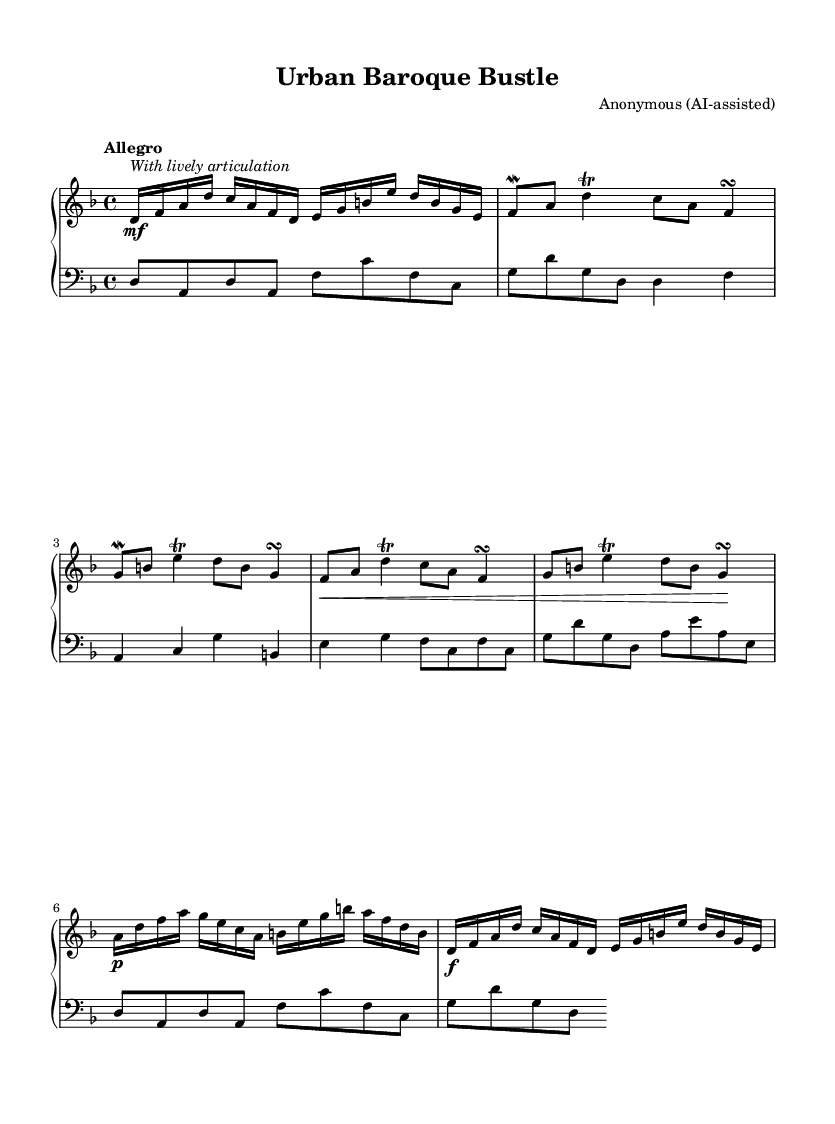What is the key signature of this music? The key signature is D minor, which has one flat (B-flat). This can be confirmed by looking at the key signature indicated at the beginning of the piece.
Answer: D minor What is the time signature of this composition? The time signature is 4/4, indicated at the beginning of the score. This means there are four beats in each measure, with a quarter note receiving one beat.
Answer: 4/4 What is the tempo marking given for this piece? The tempo marking is "Allegro," which indicates a fast and lively pace for the performance of the music. This is stated explicitly at the beginning of the piece.
Answer: Allegro How many sections does this composition have? There are three distinct sections in this composition, each characterized by different musical ideas labeled A, B, and C. The A section is repeated at the end, making it four appearances in total.
Answer: 3 What dynamic marking appears at the start of Section A? At the start of Section A, the dynamic marking is marked as "mf" (mezzo-forte), which instructs the performer to play moderately loud. This is noted directly above the first notes of Section A.
Answer: mf What type of ornamentations are used in this score? The score contains mordents and trills, which are types of ornamentation commonly used in Baroque music to embellish the melody. This can be identified by the symbols placed above the respective notes in the score.
Answer: Mordents and trills 